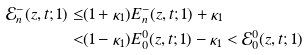Convert formula to latex. <formula><loc_0><loc_0><loc_500><loc_500>\mathcal { E } _ { n } ^ { - } ( z , t ; 1 ) \leq & ( 1 + \kappa _ { 1 } ) E _ { n } ^ { - } ( z , t ; 1 ) + \kappa _ { 1 } \\ < & ( 1 - \kappa _ { 1 } ) E _ { 0 } ^ { 0 } ( z , t ; 1 ) - \kappa _ { 1 } < \mathcal { E } _ { 0 } ^ { 0 } ( z , t ; 1 )</formula> 